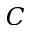Convert formula to latex. <formula><loc_0><loc_0><loc_500><loc_500>C</formula> 